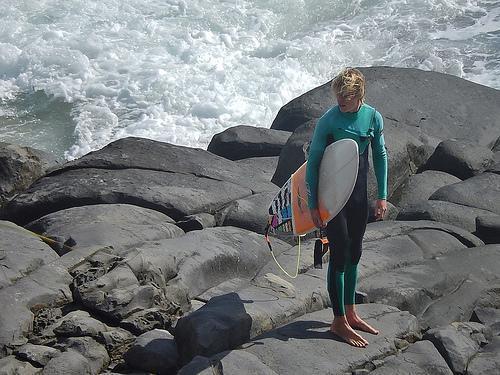How many surfboards does he have?
Give a very brief answer. 1. 